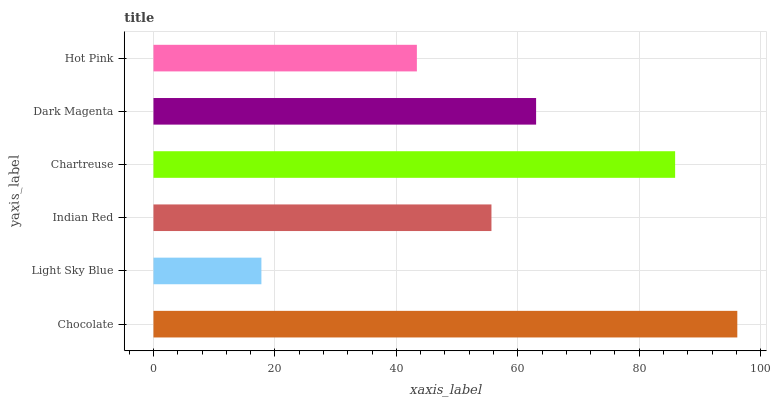Is Light Sky Blue the minimum?
Answer yes or no. Yes. Is Chocolate the maximum?
Answer yes or no. Yes. Is Indian Red the minimum?
Answer yes or no. No. Is Indian Red the maximum?
Answer yes or no. No. Is Indian Red greater than Light Sky Blue?
Answer yes or no. Yes. Is Light Sky Blue less than Indian Red?
Answer yes or no. Yes. Is Light Sky Blue greater than Indian Red?
Answer yes or no. No. Is Indian Red less than Light Sky Blue?
Answer yes or no. No. Is Dark Magenta the high median?
Answer yes or no. Yes. Is Indian Red the low median?
Answer yes or no. Yes. Is Indian Red the high median?
Answer yes or no. No. Is Chartreuse the low median?
Answer yes or no. No. 